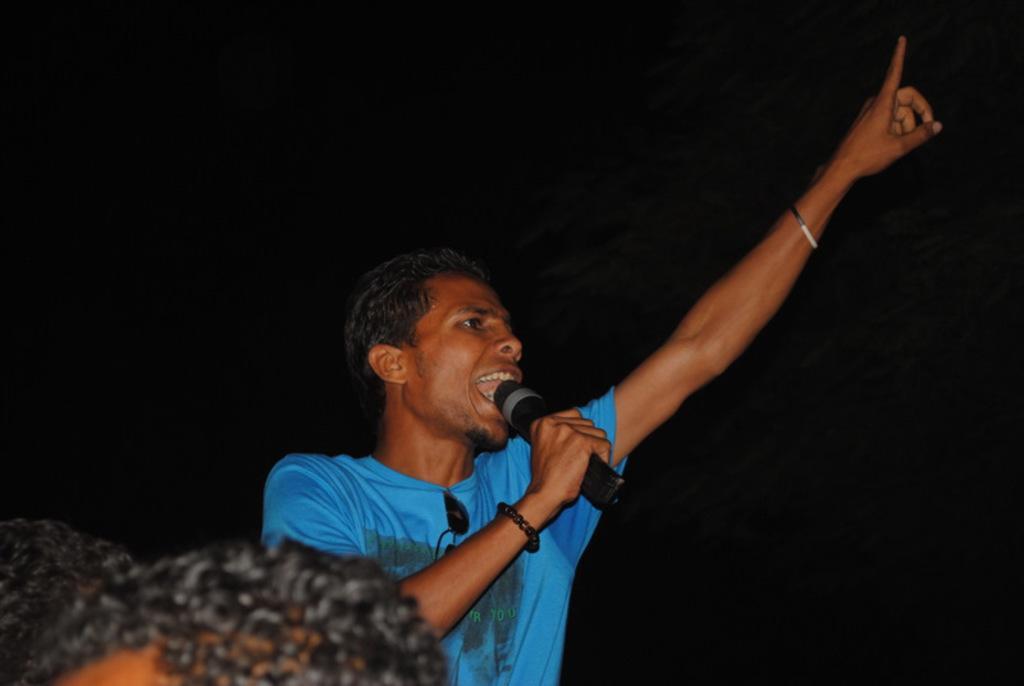Please provide a concise description of this image. In the center of the image we can see a person is standing and he is holding a microphone. At the bottom left side of the image, we can see the heads of persons. And we can see the dark background. 